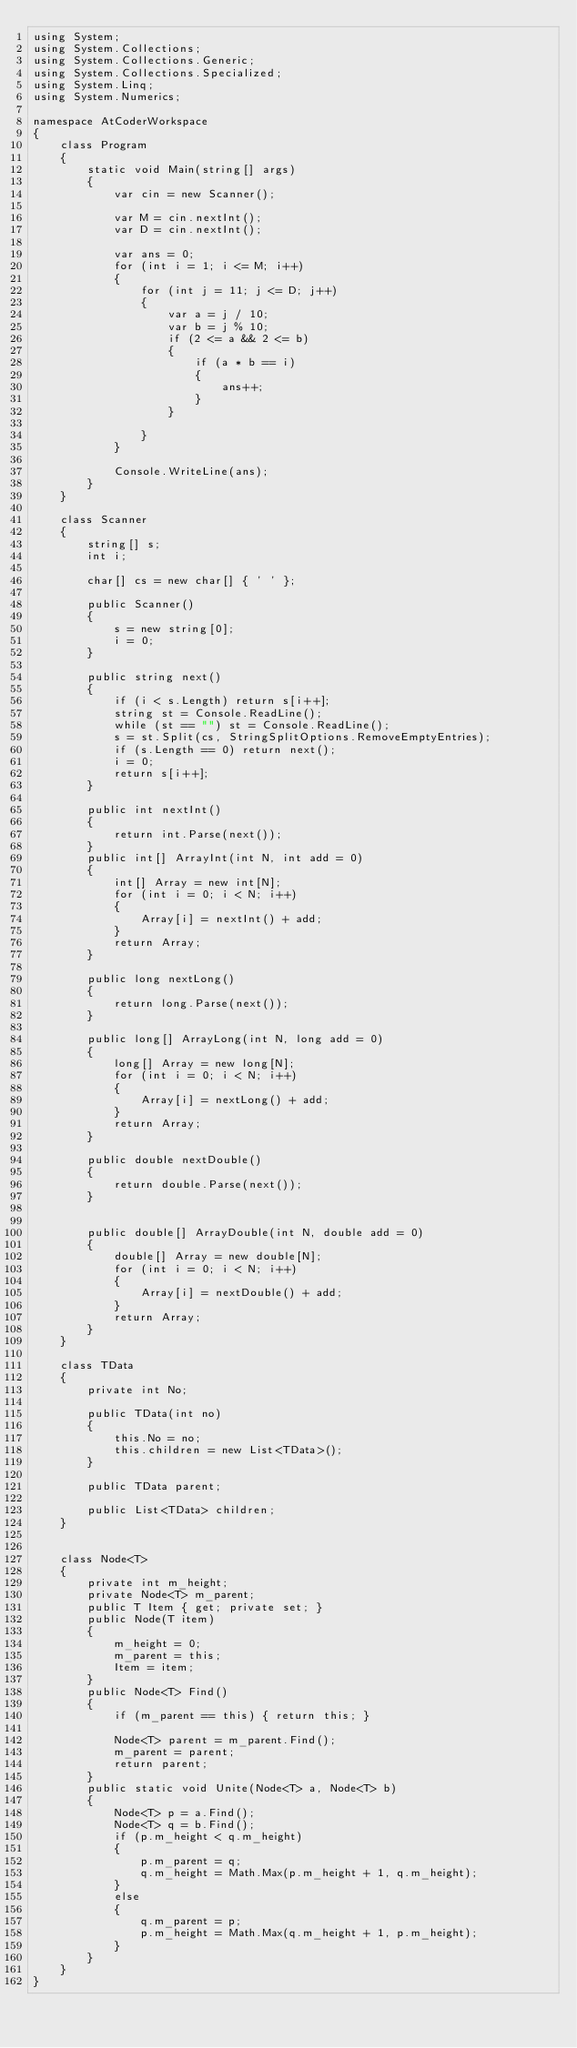<code> <loc_0><loc_0><loc_500><loc_500><_C#_>using System;
using System.Collections;
using System.Collections.Generic;
using System.Collections.Specialized;
using System.Linq;
using System.Numerics;

namespace AtCoderWorkspace
{
    class Program
    {
        static void Main(string[] args)
        {
            var cin = new Scanner();
            
            var M = cin.nextInt();
            var D = cin.nextInt();

            var ans = 0;
            for (int i = 1; i <= M; i++)
            {
                for (int j = 11; j <= D; j++)
                {
                    var a = j / 10;
                    var b = j % 10;
                    if (2 <= a && 2 <= b)
                    {
                        if (a * b == i)
                        {
                            ans++;
                        }
                    }
                    
                }
            }

            Console.WriteLine(ans);
        }
    }

    class Scanner
    {
        string[] s;
        int i;

        char[] cs = new char[] { ' ' };

        public Scanner()
        {
            s = new string[0];
            i = 0;
        }

        public string next()
        {
            if (i < s.Length) return s[i++];
            string st = Console.ReadLine();
            while (st == "") st = Console.ReadLine();
            s = st.Split(cs, StringSplitOptions.RemoveEmptyEntries);
            if (s.Length == 0) return next();
            i = 0;
            return s[i++];
        }

        public int nextInt()
        {
            return int.Parse(next());
        }
        public int[] ArrayInt(int N, int add = 0)
        {
            int[] Array = new int[N];
            for (int i = 0; i < N; i++)
            {
                Array[i] = nextInt() + add;
            }
            return Array;
        }

        public long nextLong()
        {
            return long.Parse(next());
        }

        public long[] ArrayLong(int N, long add = 0)
        {
            long[] Array = new long[N];
            for (int i = 0; i < N; i++)
            {
                Array[i] = nextLong() + add;
            }
            return Array;
        }

        public double nextDouble()
        {
            return double.Parse(next());
        }


        public double[] ArrayDouble(int N, double add = 0)
        {
            double[] Array = new double[N];
            for (int i = 0; i < N; i++)
            {
                Array[i] = nextDouble() + add;
            }
            return Array;
        }
    }

    class TData
    {
        private int No;

        public TData(int no)
        {
            this.No = no;
            this.children = new List<TData>();
        }

        public TData parent;

        public List<TData> children;
    }


    class Node<T>
    {
        private int m_height;
        private Node<T> m_parent;
        public T Item { get; private set; }
        public Node(T item)
        {
            m_height = 0;
            m_parent = this;
            Item = item;
        }
        public Node<T> Find()
        {
            if (m_parent == this) { return this; }

            Node<T> parent = m_parent.Find();
            m_parent = parent;
            return parent;
        }
        public static void Unite(Node<T> a, Node<T> b)
        {
            Node<T> p = a.Find();
            Node<T> q = b.Find();
            if (p.m_height < q.m_height)
            {
                p.m_parent = q;
                q.m_height = Math.Max(p.m_height + 1, q.m_height);
            }
            else
            {
                q.m_parent = p;
                p.m_height = Math.Max(q.m_height + 1, p.m_height);
            }
        }
    }
}
</code> 